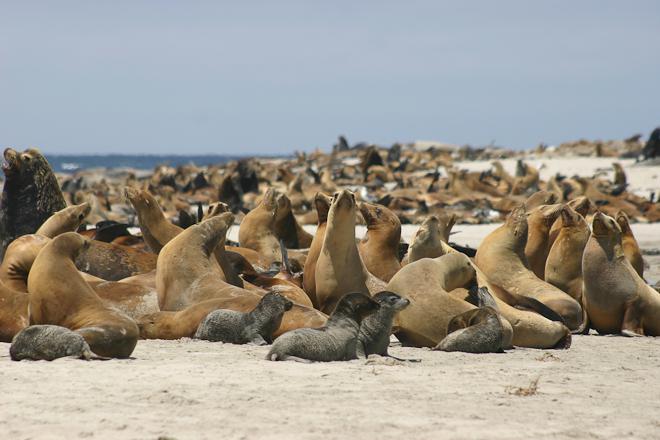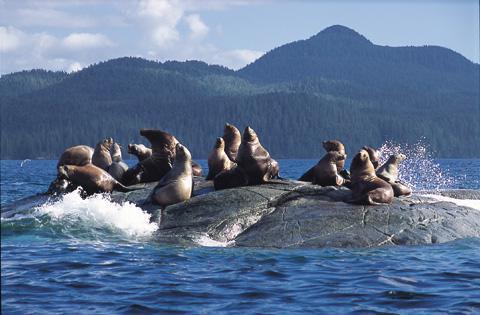The first image is the image on the left, the second image is the image on the right. Evaluate the accuracy of this statement regarding the images: "One image shows seals above the water, sharing piles of rocks with birds.". Is it true? Answer yes or no. No. The first image is the image on the left, the second image is the image on the right. Assess this claim about the two images: "Some of the sea lions are swimming in open water.". Correct or not? Answer yes or no. No. 